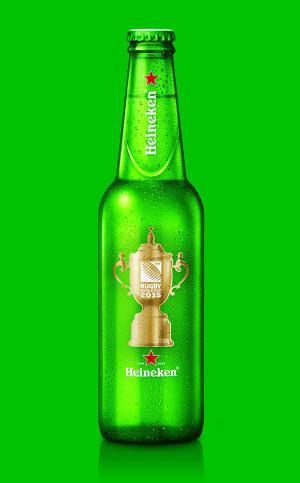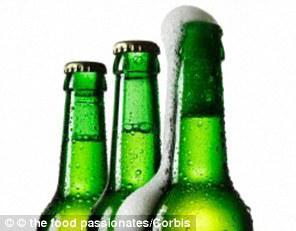The first image is the image on the left, the second image is the image on the right. Assess this claim about the two images: "A single green beer bottle is shown in one image.". Correct or not? Answer yes or no. Yes. The first image is the image on the left, the second image is the image on the right. Evaluate the accuracy of this statement regarding the images: "An image contains exactly two bottles displayed vertically.". Is it true? Answer yes or no. No. 